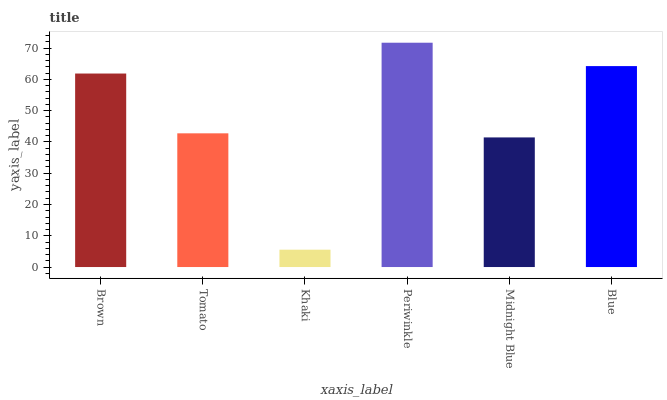Is Khaki the minimum?
Answer yes or no. Yes. Is Periwinkle the maximum?
Answer yes or no. Yes. Is Tomato the minimum?
Answer yes or no. No. Is Tomato the maximum?
Answer yes or no. No. Is Brown greater than Tomato?
Answer yes or no. Yes. Is Tomato less than Brown?
Answer yes or no. Yes. Is Tomato greater than Brown?
Answer yes or no. No. Is Brown less than Tomato?
Answer yes or no. No. Is Brown the high median?
Answer yes or no. Yes. Is Tomato the low median?
Answer yes or no. Yes. Is Khaki the high median?
Answer yes or no. No. Is Blue the low median?
Answer yes or no. No. 